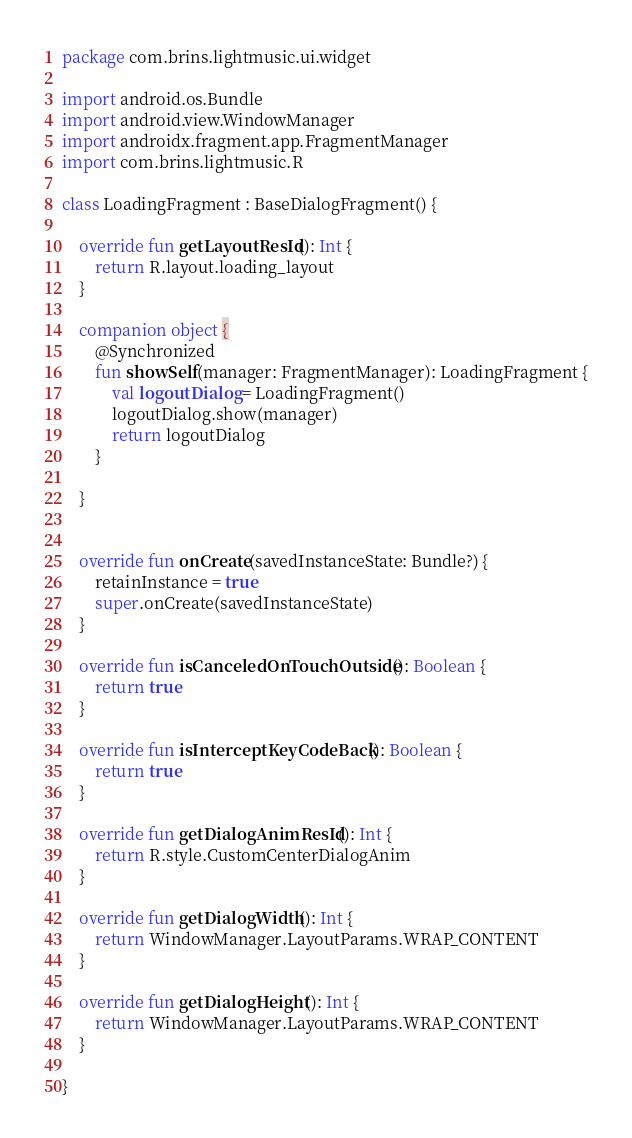<code> <loc_0><loc_0><loc_500><loc_500><_Kotlin_>package com.brins.lightmusic.ui.widget

import android.os.Bundle
import android.view.WindowManager
import androidx.fragment.app.FragmentManager
import com.brins.lightmusic.R

class LoadingFragment : BaseDialogFragment() {

    override fun getLayoutResId(): Int {
        return R.layout.loading_layout
    }

    companion object {
        @Synchronized
        fun showSelf(manager: FragmentManager): LoadingFragment {
            val logoutDialog = LoadingFragment()
            logoutDialog.show(manager)
            return logoutDialog
        }

    }


    override fun onCreate(savedInstanceState: Bundle?) {
        retainInstance = true
        super.onCreate(savedInstanceState)
    }

    override fun isCanceledOnTouchOutside(): Boolean {
        return true
    }

    override fun isInterceptKeyCodeBack(): Boolean {
        return true
    }

    override fun getDialogAnimResId(): Int {
        return R.style.CustomCenterDialogAnim
    }

    override fun getDialogWidth(): Int {
        return WindowManager.LayoutParams.WRAP_CONTENT
    }

    override fun getDialogHeight(): Int {
        return WindowManager.LayoutParams.WRAP_CONTENT
    }

}</code> 